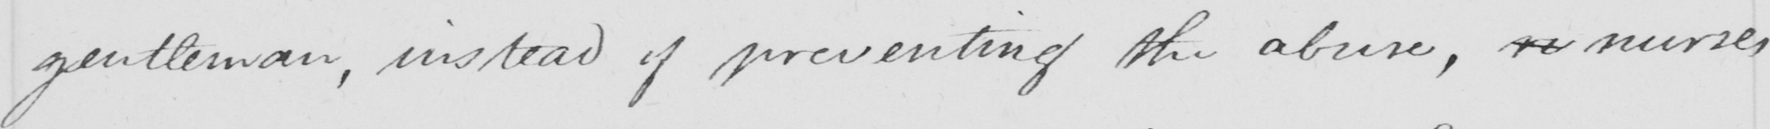Can you read and transcribe this handwriting? gentleman , instead of preventing the abuse , re nurses 